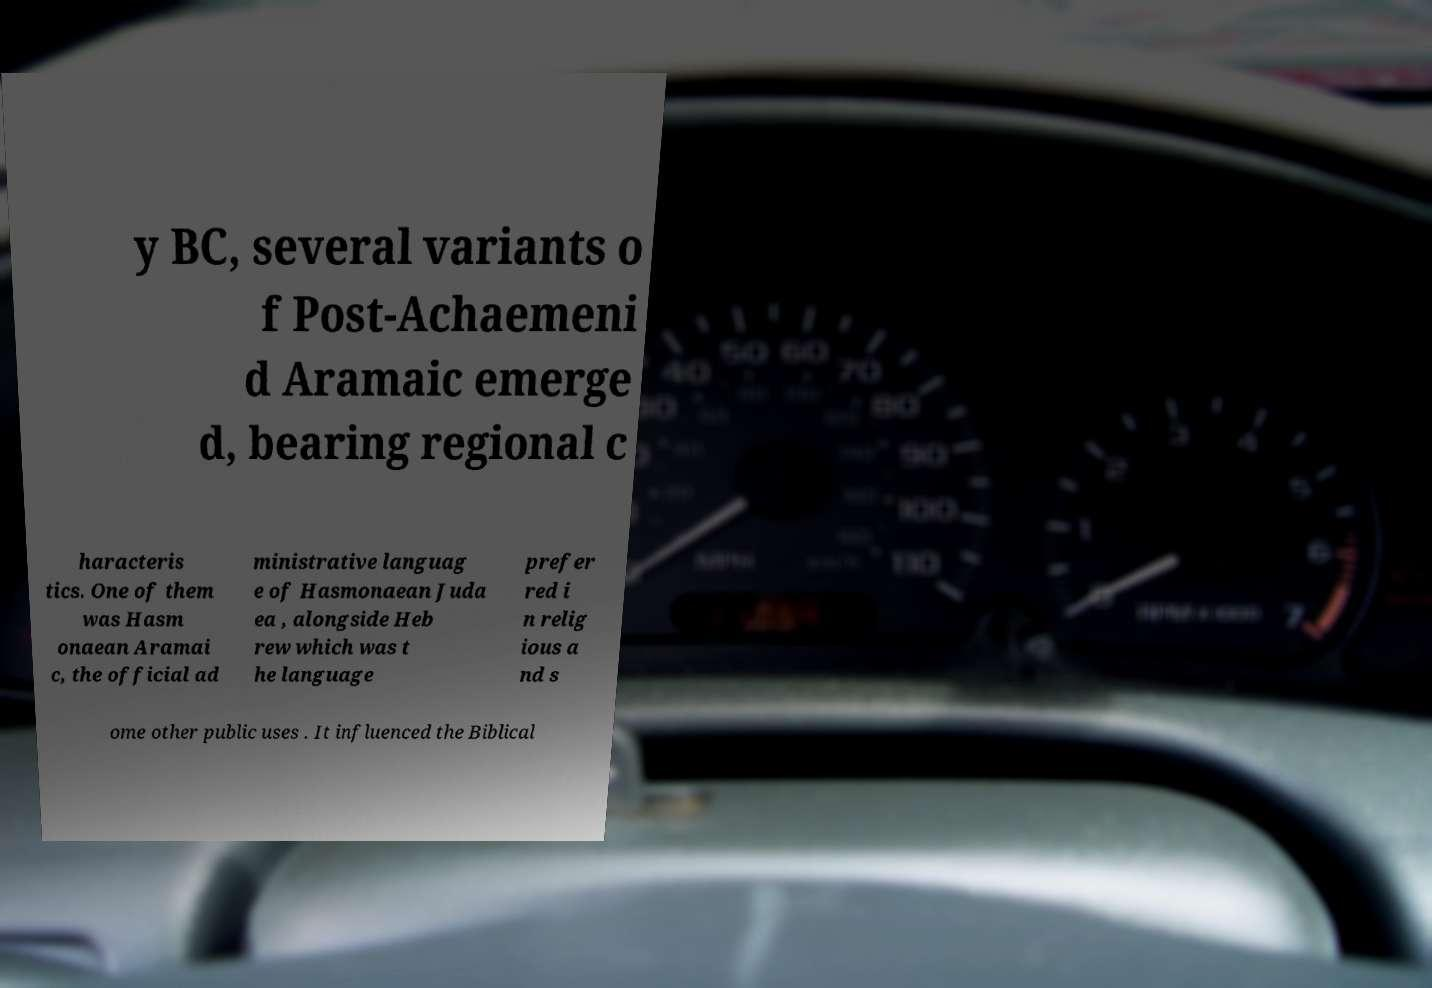Can you read and provide the text displayed in the image?This photo seems to have some interesting text. Can you extract and type it out for me? y BC, several variants o f Post-Achaemeni d Aramaic emerge d, bearing regional c haracteris tics. One of them was Hasm onaean Aramai c, the official ad ministrative languag e of Hasmonaean Juda ea , alongside Heb rew which was t he language prefer red i n relig ious a nd s ome other public uses . It influenced the Biblical 